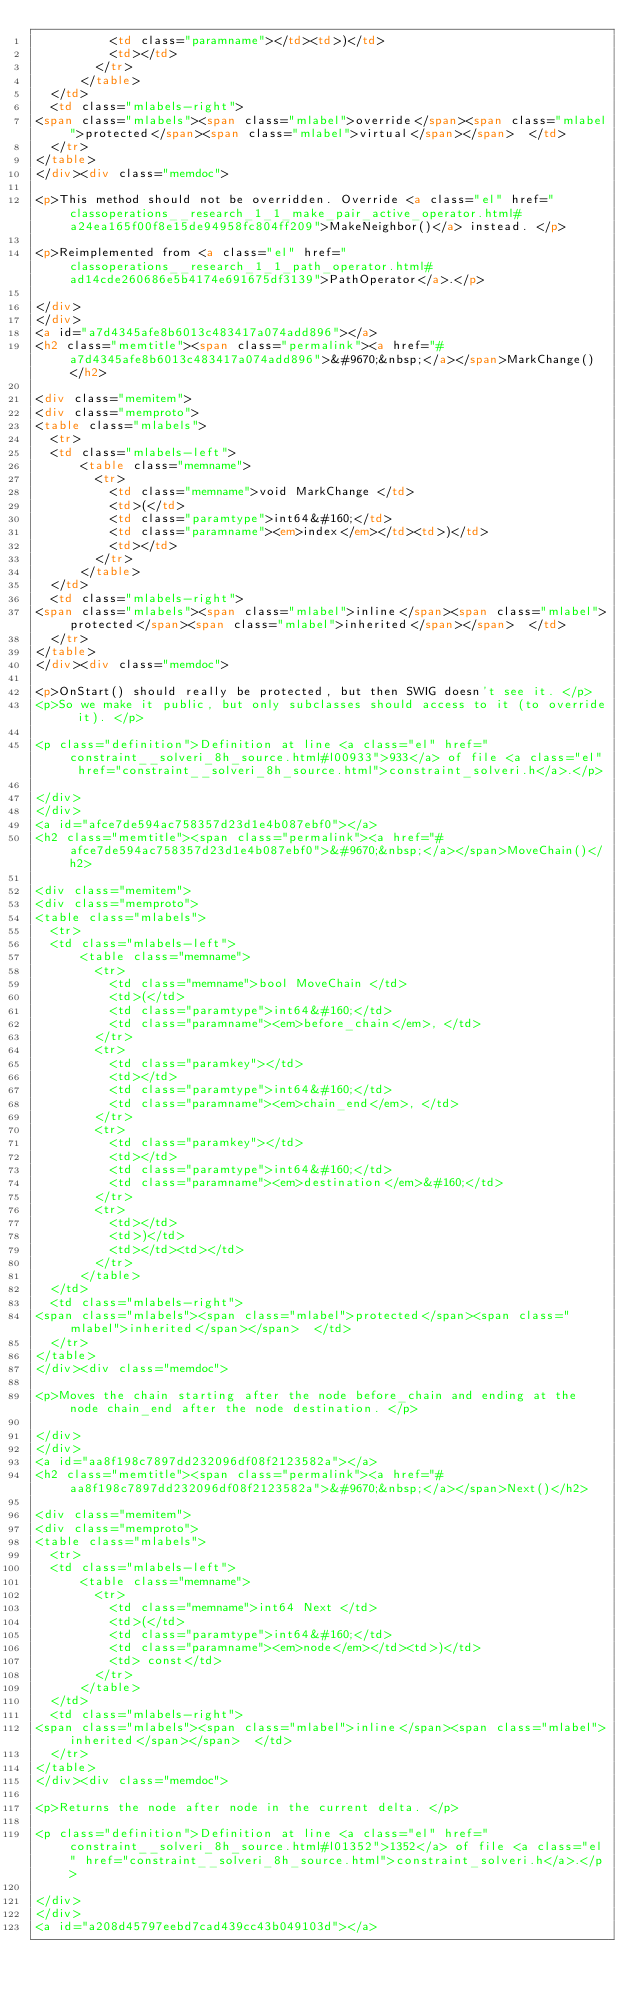<code> <loc_0><loc_0><loc_500><loc_500><_HTML_>          <td class="paramname"></td><td>)</td>
          <td></td>
        </tr>
      </table>
  </td>
  <td class="mlabels-right">
<span class="mlabels"><span class="mlabel">override</span><span class="mlabel">protected</span><span class="mlabel">virtual</span></span>  </td>
  </tr>
</table>
</div><div class="memdoc">

<p>This method should not be overridden. Override <a class="el" href="classoperations__research_1_1_make_pair_active_operator.html#a24ea165f00f8e15de94958fc804ff209">MakeNeighbor()</a> instead. </p>

<p>Reimplemented from <a class="el" href="classoperations__research_1_1_path_operator.html#ad14cde260686e5b4174e691675df3139">PathOperator</a>.</p>

</div>
</div>
<a id="a7d4345afe8b6013c483417a074add896"></a>
<h2 class="memtitle"><span class="permalink"><a href="#a7d4345afe8b6013c483417a074add896">&#9670;&nbsp;</a></span>MarkChange()</h2>

<div class="memitem">
<div class="memproto">
<table class="mlabels">
  <tr>
  <td class="mlabels-left">
      <table class="memname">
        <tr>
          <td class="memname">void MarkChange </td>
          <td>(</td>
          <td class="paramtype">int64&#160;</td>
          <td class="paramname"><em>index</em></td><td>)</td>
          <td></td>
        </tr>
      </table>
  </td>
  <td class="mlabels-right">
<span class="mlabels"><span class="mlabel">inline</span><span class="mlabel">protected</span><span class="mlabel">inherited</span></span>  </td>
  </tr>
</table>
</div><div class="memdoc">

<p>OnStart() should really be protected, but then SWIG doesn't see it. </p>
<p>So we make it public, but only subclasses should access to it (to override it). </p>

<p class="definition">Definition at line <a class="el" href="constraint__solveri_8h_source.html#l00933">933</a> of file <a class="el" href="constraint__solveri_8h_source.html">constraint_solveri.h</a>.</p>

</div>
</div>
<a id="afce7de594ac758357d23d1e4b087ebf0"></a>
<h2 class="memtitle"><span class="permalink"><a href="#afce7de594ac758357d23d1e4b087ebf0">&#9670;&nbsp;</a></span>MoveChain()</h2>

<div class="memitem">
<div class="memproto">
<table class="mlabels">
  <tr>
  <td class="mlabels-left">
      <table class="memname">
        <tr>
          <td class="memname">bool MoveChain </td>
          <td>(</td>
          <td class="paramtype">int64&#160;</td>
          <td class="paramname"><em>before_chain</em>, </td>
        </tr>
        <tr>
          <td class="paramkey"></td>
          <td></td>
          <td class="paramtype">int64&#160;</td>
          <td class="paramname"><em>chain_end</em>, </td>
        </tr>
        <tr>
          <td class="paramkey"></td>
          <td></td>
          <td class="paramtype">int64&#160;</td>
          <td class="paramname"><em>destination</em>&#160;</td>
        </tr>
        <tr>
          <td></td>
          <td>)</td>
          <td></td><td></td>
        </tr>
      </table>
  </td>
  <td class="mlabels-right">
<span class="mlabels"><span class="mlabel">protected</span><span class="mlabel">inherited</span></span>  </td>
  </tr>
</table>
</div><div class="memdoc">

<p>Moves the chain starting after the node before_chain and ending at the node chain_end after the node destination. </p>

</div>
</div>
<a id="aa8f198c7897dd232096df08f2123582a"></a>
<h2 class="memtitle"><span class="permalink"><a href="#aa8f198c7897dd232096df08f2123582a">&#9670;&nbsp;</a></span>Next()</h2>

<div class="memitem">
<div class="memproto">
<table class="mlabels">
  <tr>
  <td class="mlabels-left">
      <table class="memname">
        <tr>
          <td class="memname">int64 Next </td>
          <td>(</td>
          <td class="paramtype">int64&#160;</td>
          <td class="paramname"><em>node</em></td><td>)</td>
          <td> const</td>
        </tr>
      </table>
  </td>
  <td class="mlabels-right">
<span class="mlabels"><span class="mlabel">inline</span><span class="mlabel">inherited</span></span>  </td>
  </tr>
</table>
</div><div class="memdoc">

<p>Returns the node after node in the current delta. </p>

<p class="definition">Definition at line <a class="el" href="constraint__solveri_8h_source.html#l01352">1352</a> of file <a class="el" href="constraint__solveri_8h_source.html">constraint_solveri.h</a>.</p>

</div>
</div>
<a id="a208d45797eebd7cad439cc43b049103d"></a></code> 